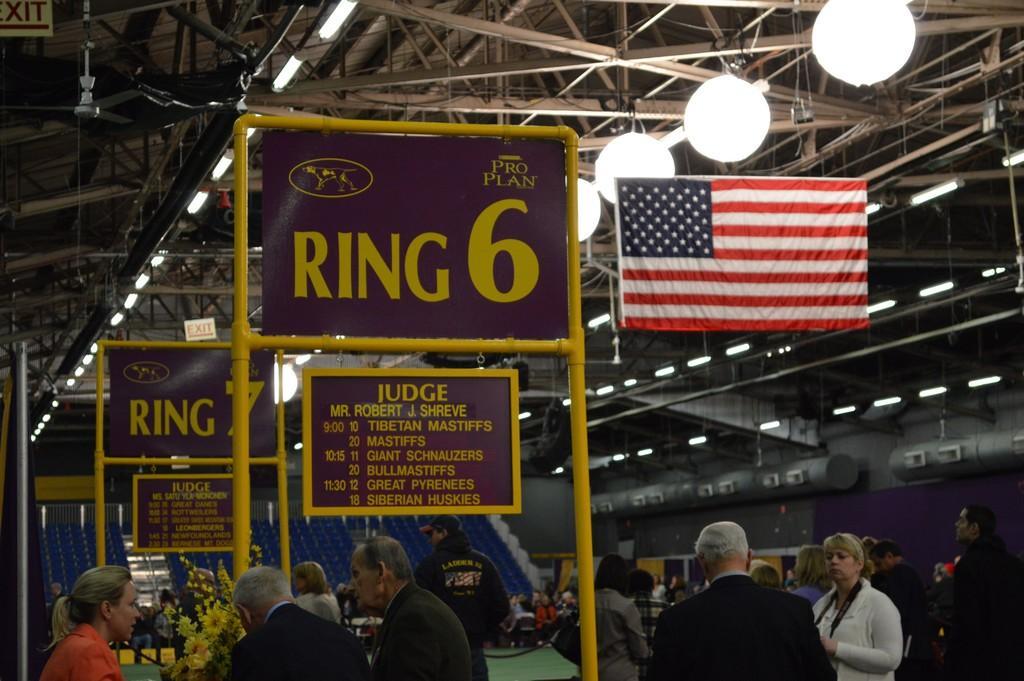In one or two sentences, can you explain what this image depicts? In this image there are group of people standing and sitting on the chairs, there is a flower bouquet, lights, flag, boards, iron rods, boards, chairs. 